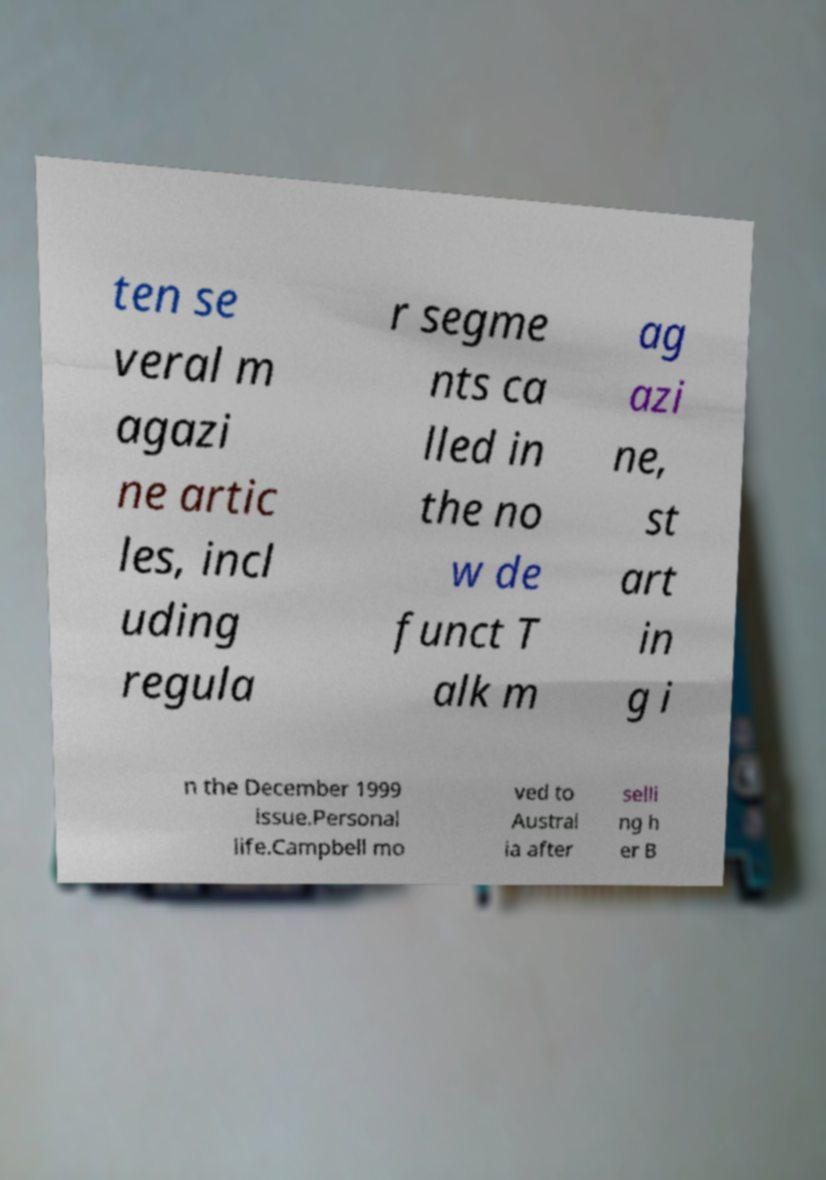Could you assist in decoding the text presented in this image and type it out clearly? ten se veral m agazi ne artic les, incl uding regula r segme nts ca lled in the no w de funct T alk m ag azi ne, st art in g i n the December 1999 issue.Personal life.Campbell mo ved to Austral ia after selli ng h er B 